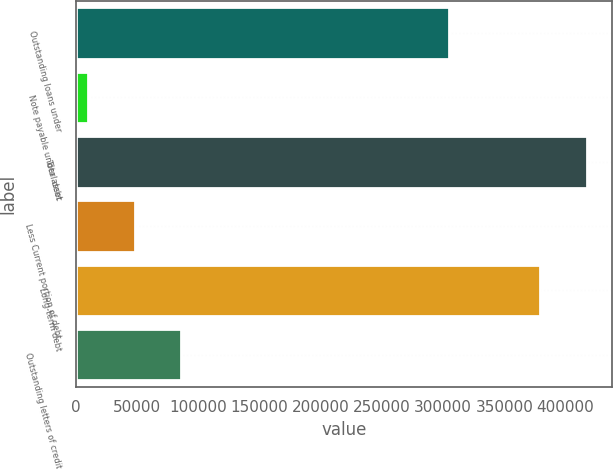Convert chart to OTSL. <chart><loc_0><loc_0><loc_500><loc_500><bar_chart><fcel>Outstanding loans under<fcel>Note payable under asset<fcel>Total debt<fcel>Less Current portion of debt<fcel>Long-term debt<fcel>Outstanding letters of credit<nl><fcel>305000<fcel>10000<fcel>417518<fcel>48000<fcel>379518<fcel>86000<nl></chart> 